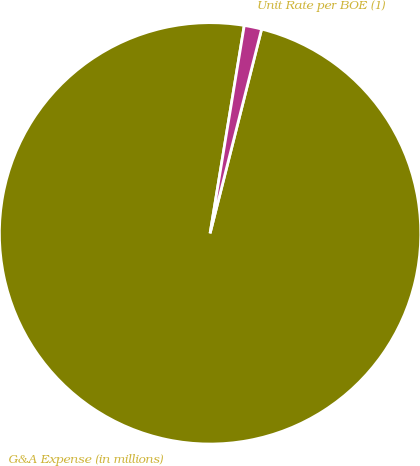<chart> <loc_0><loc_0><loc_500><loc_500><pie_chart><fcel>G&A Expense (in millions)<fcel>Unit Rate per BOE (1)<nl><fcel>98.66%<fcel>1.34%<nl></chart> 